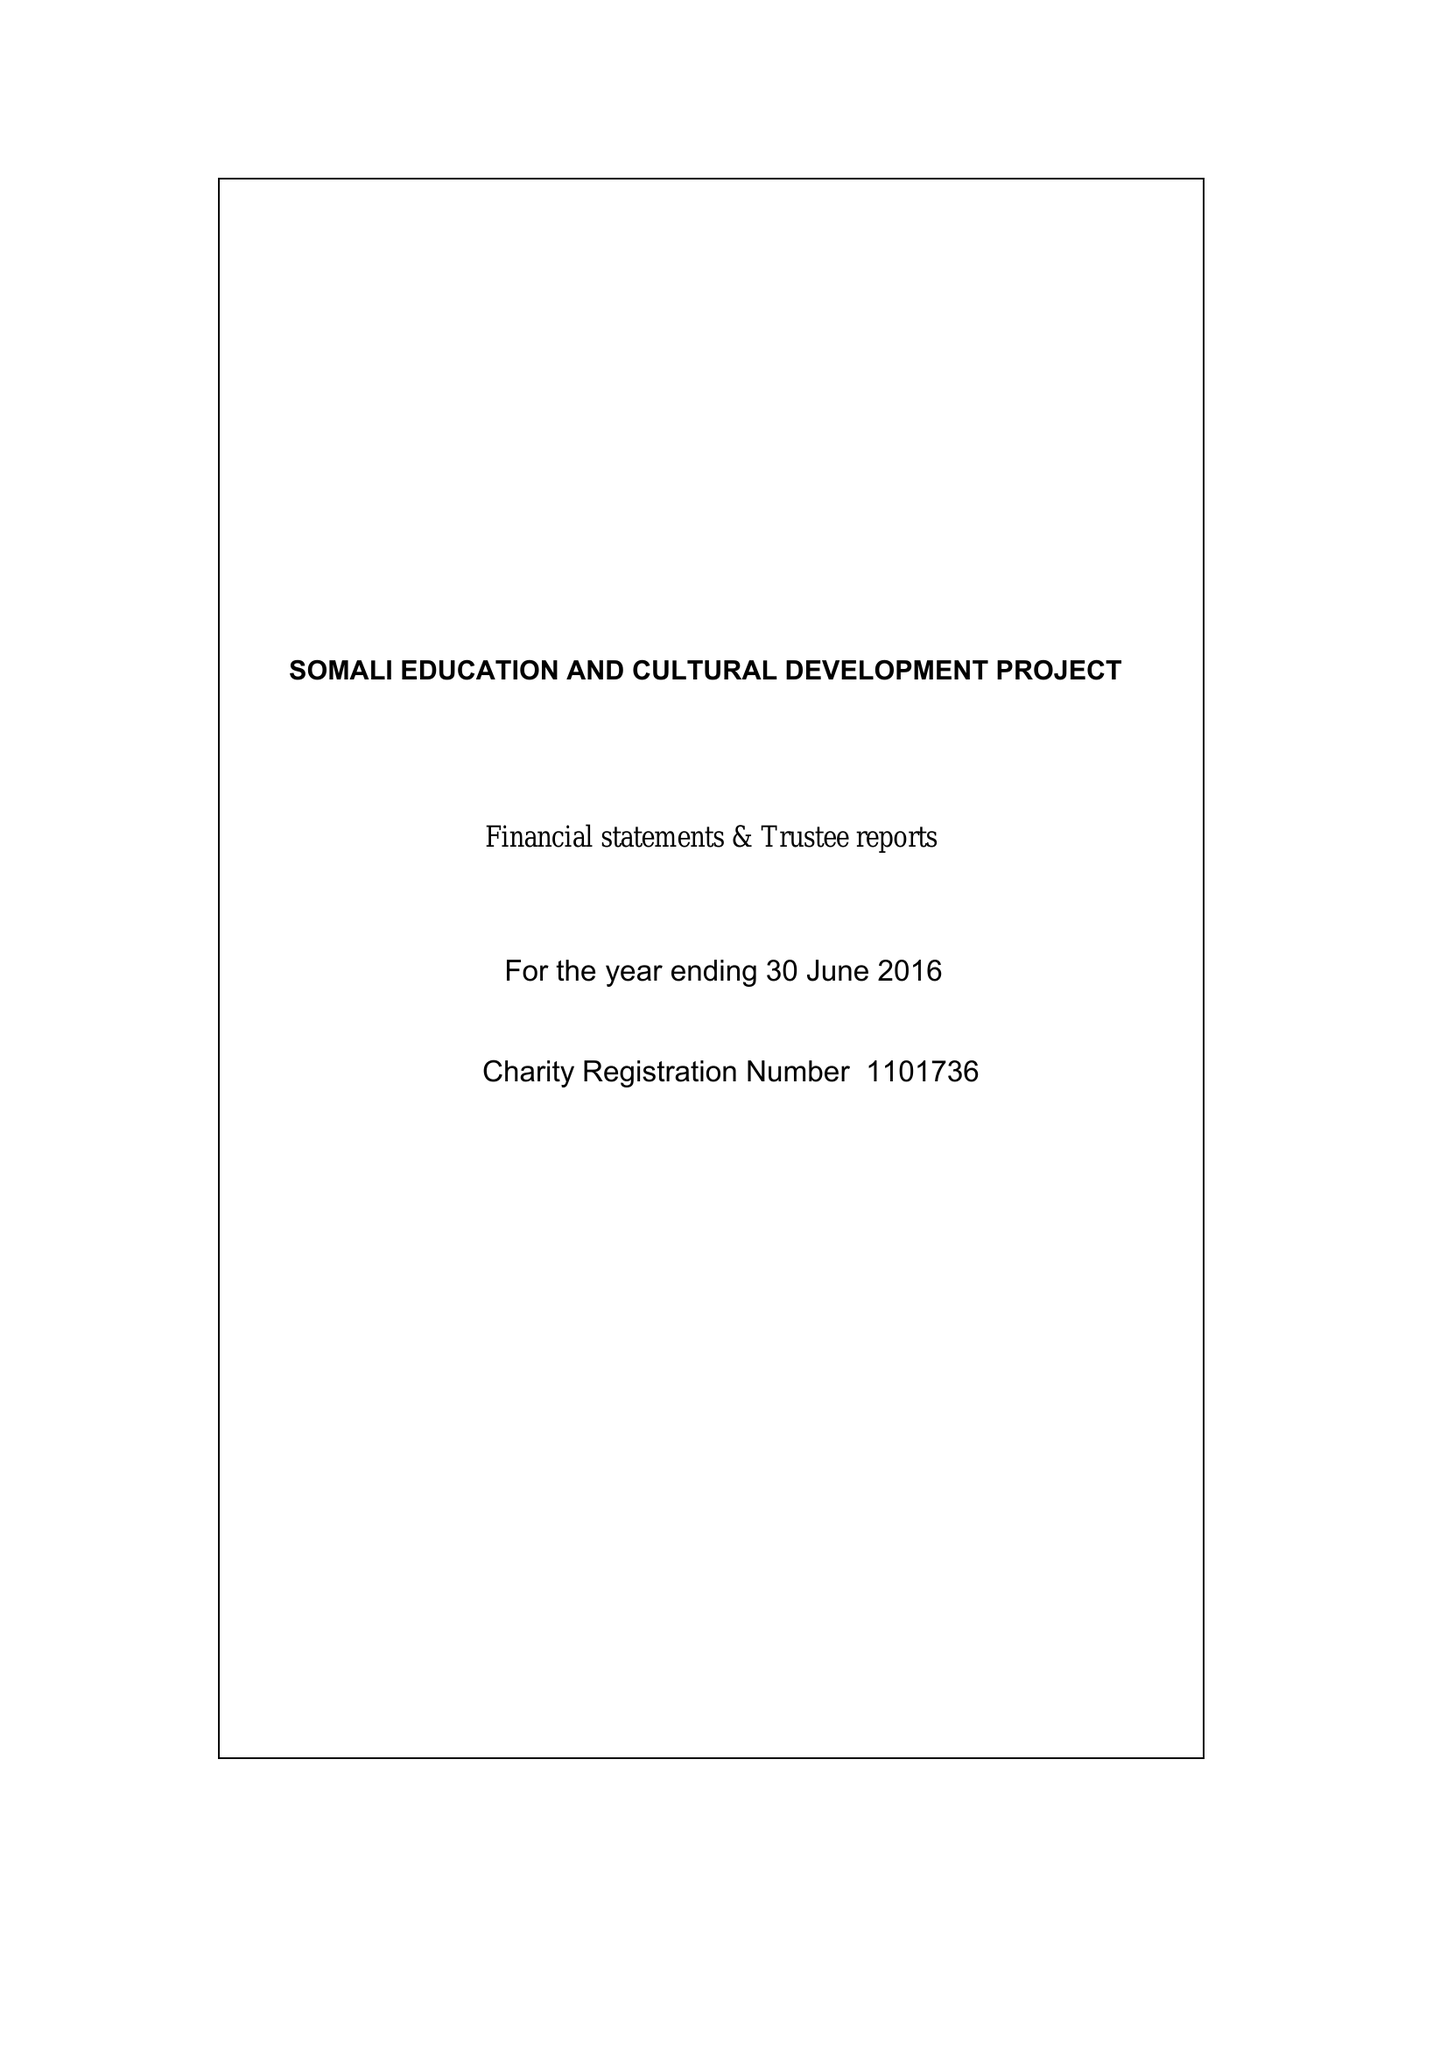What is the value for the charity_name?
Answer the question using a single word or phrase. Somali Education and Cultural Development Project 